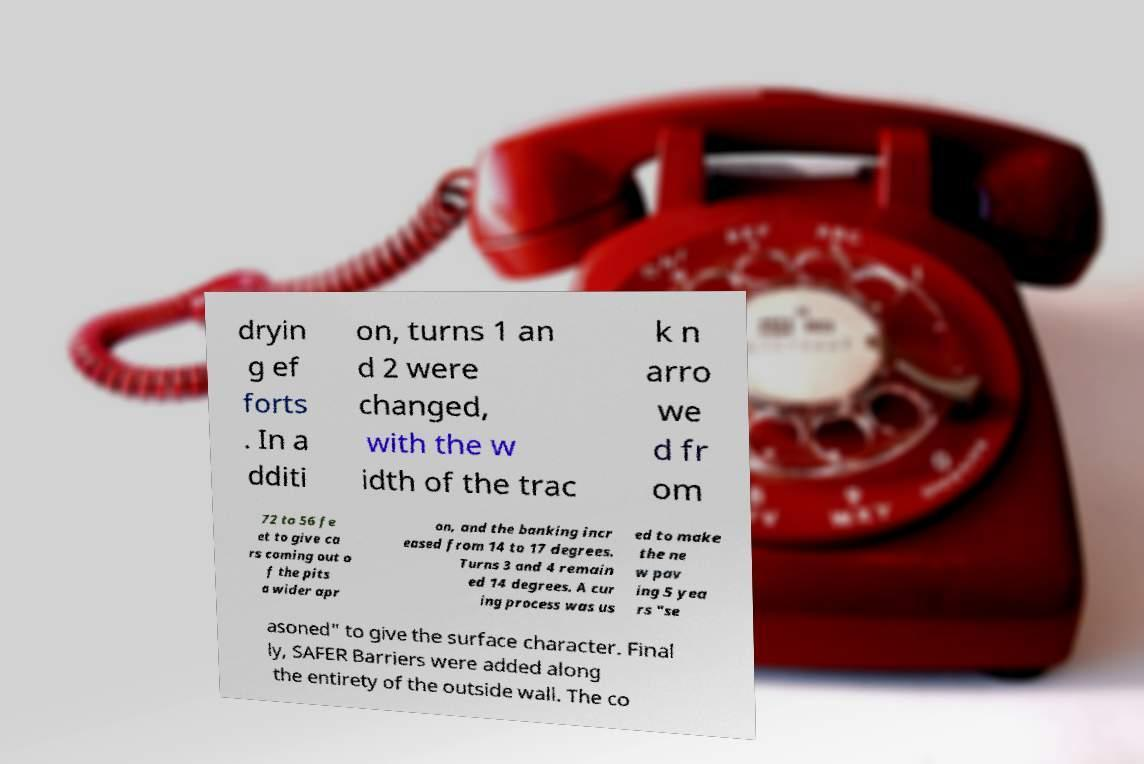Please read and relay the text visible in this image. What does it say? dryin g ef forts . In a dditi on, turns 1 an d 2 were changed, with the w idth of the trac k n arro we d fr om 72 to 56 fe et to give ca rs coming out o f the pits a wider apr on, and the banking incr eased from 14 to 17 degrees. Turns 3 and 4 remain ed 14 degrees. A cur ing process was us ed to make the ne w pav ing 5 yea rs "se asoned" to give the surface character. Final ly, SAFER Barriers were added along the entirety of the outside wall. The co 